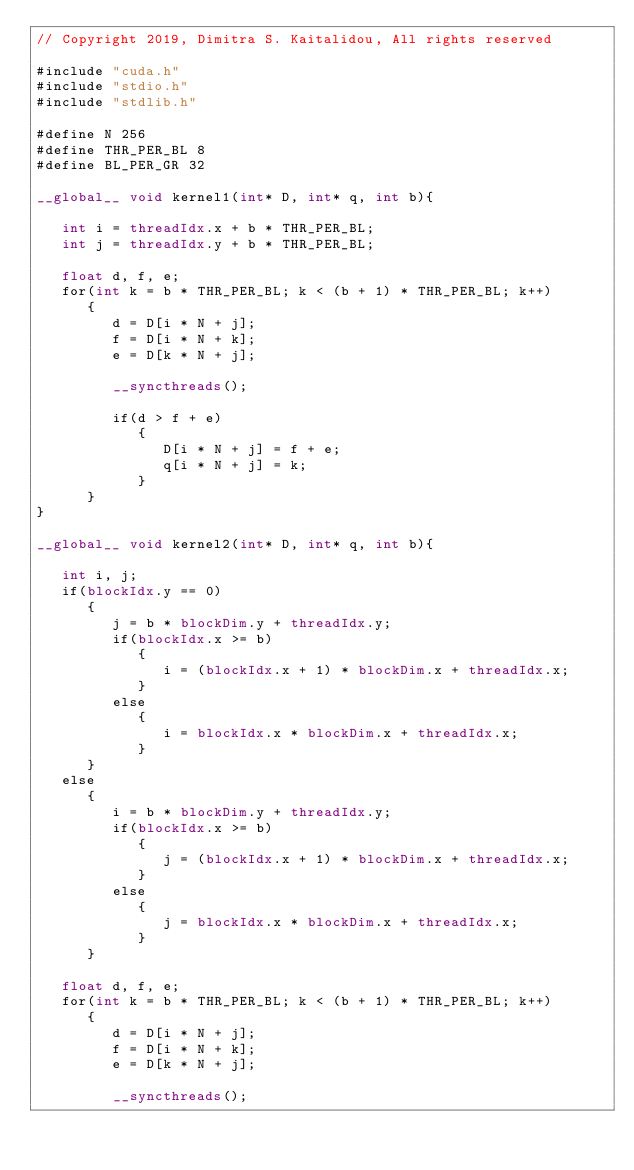Convert code to text. <code><loc_0><loc_0><loc_500><loc_500><_Cuda_>// Copyright 2019, Dimitra S. Kaitalidou, All rights reserved

#include "cuda.h"
#include "stdio.h"
#include "stdlib.h"

#define N 256
#define THR_PER_BL 8
#define BL_PER_GR 32

__global__ void kernel1(int* D, int* q, int b){

   int i = threadIdx.x + b * THR_PER_BL;
   int j = threadIdx.y + b * THR_PER_BL;

   float d, f, e;
   for(int k = b * THR_PER_BL; k < (b + 1) * THR_PER_BL; k++)
      {
         d = D[i * N + j];
         f = D[i * N + k];
         e = D[k * N + j];

         __syncthreads();

         if(d > f + e)
            {
               D[i * N + j] = f + e;
               q[i * N + j] = k;
            }
      }
}

__global__ void kernel2(int* D, int* q, int b){

   int i, j;
   if(blockIdx.y == 0)
      {
         j = b * blockDim.y + threadIdx.y;
         if(blockIdx.x >= b)
            {
               i = (blockIdx.x + 1) * blockDim.x + threadIdx.x;
            }
         else
            {
               i = blockIdx.x * blockDim.x + threadIdx.x;
            }
      }
   else
      {
         i = b * blockDim.y + threadIdx.y;
         if(blockIdx.x >= b)
            {
               j = (blockIdx.x + 1) * blockDim.x + threadIdx.x;
            }
         else
            {
               j = blockIdx.x * blockDim.x + threadIdx.x;
            }
      }

   float d, f, e;
   for(int k = b * THR_PER_BL; k < (b + 1) * THR_PER_BL; k++)
      {
         d = D[i * N + j];
         f = D[i * N + k];
         e = D[k * N + j];

         __syncthreads();</code> 